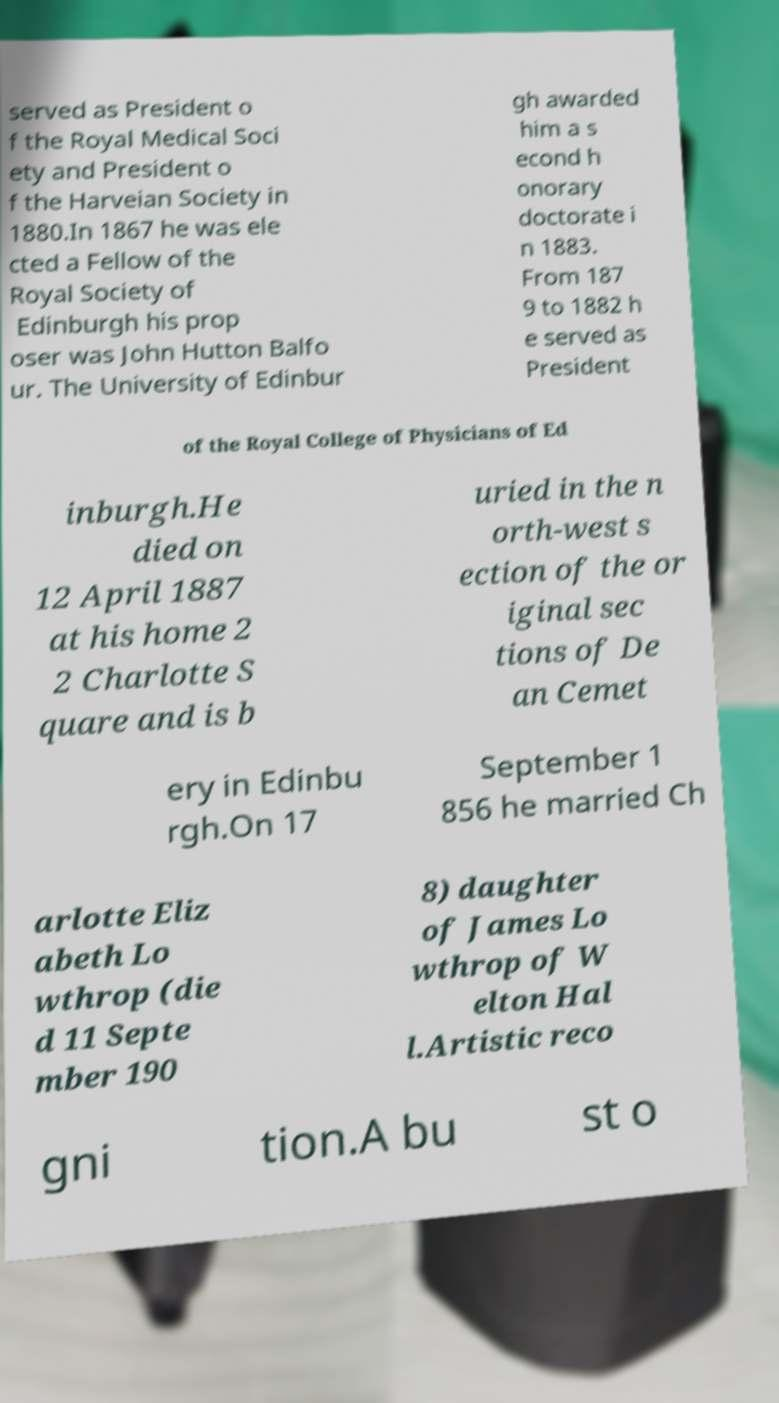Please identify and transcribe the text found in this image. served as President o f the Royal Medical Soci ety and President o f the Harveian Society in 1880.In 1867 he was ele cted a Fellow of the Royal Society of Edinburgh his prop oser was John Hutton Balfo ur. The University of Edinbur gh awarded him a s econd h onorary doctorate i n 1883. From 187 9 to 1882 h e served as President of the Royal College of Physicians of Ed inburgh.He died on 12 April 1887 at his home 2 2 Charlotte S quare and is b uried in the n orth-west s ection of the or iginal sec tions of De an Cemet ery in Edinbu rgh.On 17 September 1 856 he married Ch arlotte Eliz abeth Lo wthrop (die d 11 Septe mber 190 8) daughter of James Lo wthrop of W elton Hal l.Artistic reco gni tion.A bu st o 